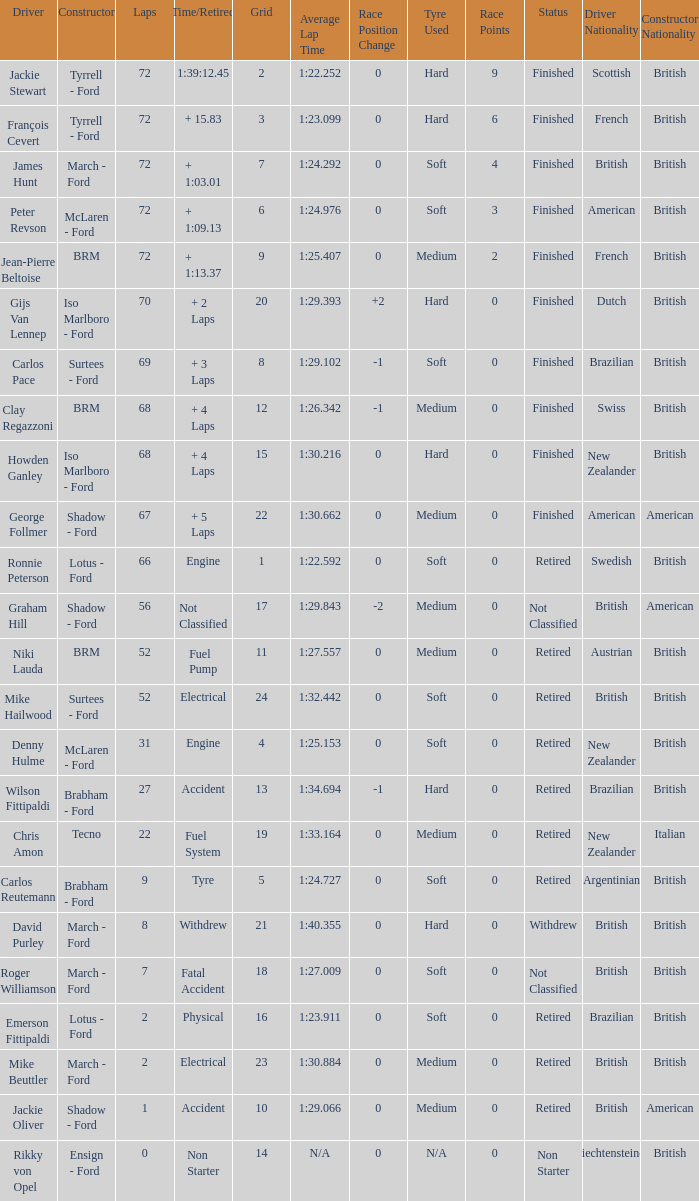What is the top grid that laps less than 66 and a retried engine? 4.0. 